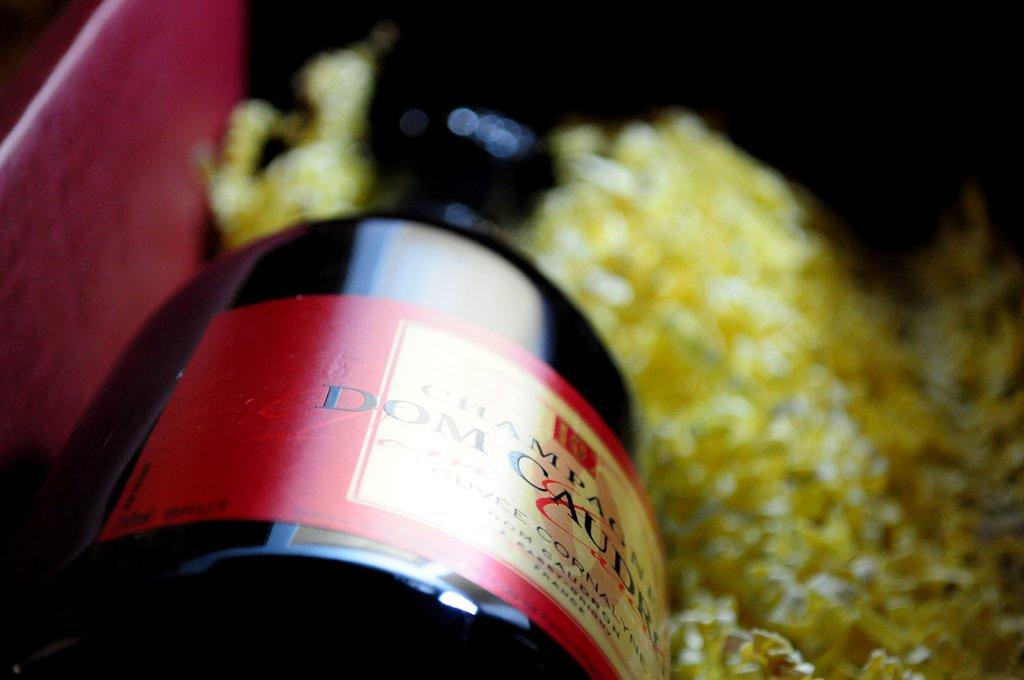<image>
Present a compact description of the photo's key features. A bottle of Dom Caudru Champagne in a red box with yellow confetti type packing material. 